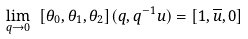Convert formula to latex. <formula><loc_0><loc_0><loc_500><loc_500>\lim _ { q \to 0 } \ [ \theta _ { 0 } , \theta _ { 1 } , \theta _ { 2 } ] & ( q , q ^ { - 1 } u ) = [ 1 , \overline { u } , 0 ]</formula> 